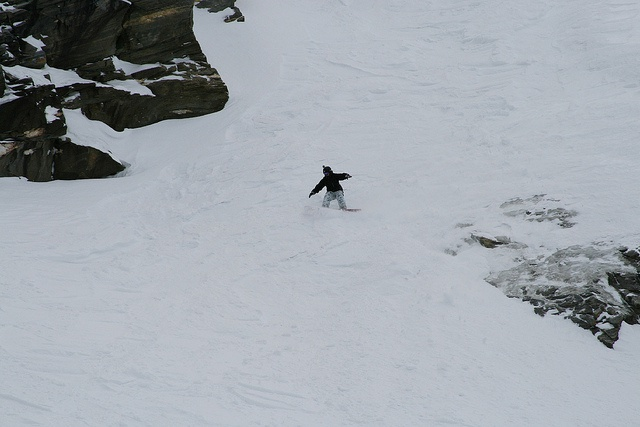Describe the objects in this image and their specific colors. I can see people in black, gray, and darkgray tones and snowboard in black and gray tones in this image. 